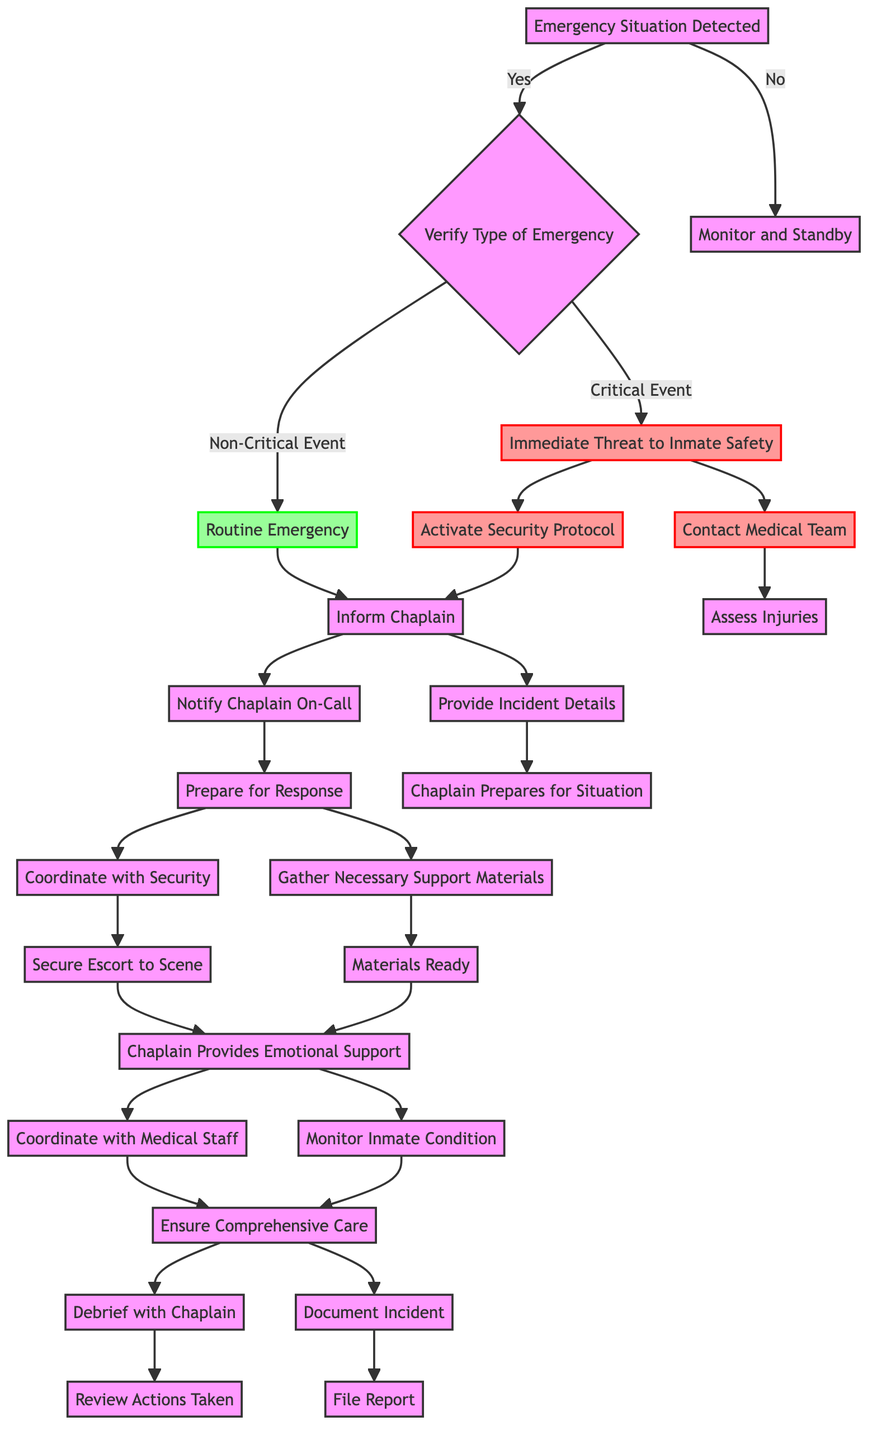What happens if an emergency situation is detected? If an emergency situation is detected, it leads to the next step of verifying the type of emergency, which then determines the subsequent actions to be taken based on whether it is critical or non-critical.
Answer: Verify Type of Emergency What is the first action taken for a critical event? The first action taken for a critical event, specifically for an immediate threat to inmate safety, is to activate the security protocol. This action is necessary to address the emergency effectively.
Answer: Activate Security Protocol How many main steps are there when an emergency is identified? There are three main steps when an emergency is identified: verify the type of emergency, monitor and standby if no emergency is detected, and the two follow-up paths for critical and routine emergencies. This includes critical and non-critical outcomes leading to different actions.
Answer: Three What does the chaplain do after being informed? After being informed, the chaplain is notified on-call to prepare for the response. This essential step ensures that the chaplain is adequately prepared to address the situation accordingly.
Answer: Prepare for Response What is the result of the action 'Coordinate with Security'? The result of the action 'Coordinate with Security' is to secure an escort to the scene, which is crucial for ensuring that the chaplain can safely access the area of the emergency.
Answer: Secure Escort to Scene What is the relationship between 'Immediate Threat to Inmate Safety' and 'Assess Injuries'? The relationship is that 'Immediate Threat to Inmate Safety' leads directly to actions like activating the security protocol and contacting the medical team, with 'Assess Injuries' being one of the subsequent results following medical team contact. This shows a direct sequential dependency between these actions.
Answer: Sequential Dependency What follows after the action 'Chaplain Provides Emotional Support'? After the action 'Chaplain Provides Emotional Support', the chaplain either monitors the inmate's condition or coordinates with medical staff to ensure comprehensive care. This indicates ongoing support and care management during the emergency response.
Answer: Monitor Inmate Condition & Coordinate with Medical Staff How do you document the incident? The incident is documented through the action of filing a report, which is the final step of completion and follow-up after reviewing actions taken with the chaplain. This ensures that all events are recorded officially for review.
Answer: File Report 